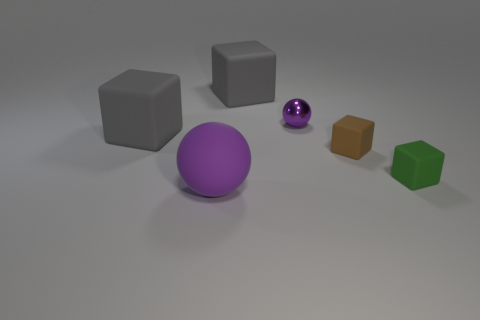What size is the purple sphere that is behind the big purple rubber object?
Offer a terse response. Small. Do the tiny purple object and the large sphere have the same material?
Provide a succinct answer. No. The green object that is the same material as the large purple ball is what shape?
Your answer should be very brief. Cube. Is there any other thing that has the same color as the large sphere?
Provide a short and direct response. Yes. What color is the matte thing on the left side of the purple rubber sphere?
Give a very brief answer. Gray. There is a thing behind the shiny sphere; is its color the same as the big ball?
Provide a short and direct response. No. There is a brown object that is the same shape as the green thing; what is its material?
Ensure brevity in your answer.  Rubber. How many objects are the same size as the green rubber block?
Provide a succinct answer. 2. What is the shape of the small brown object?
Your answer should be compact. Cube. What is the size of the object that is both behind the large purple matte object and in front of the tiny brown thing?
Provide a succinct answer. Small. 